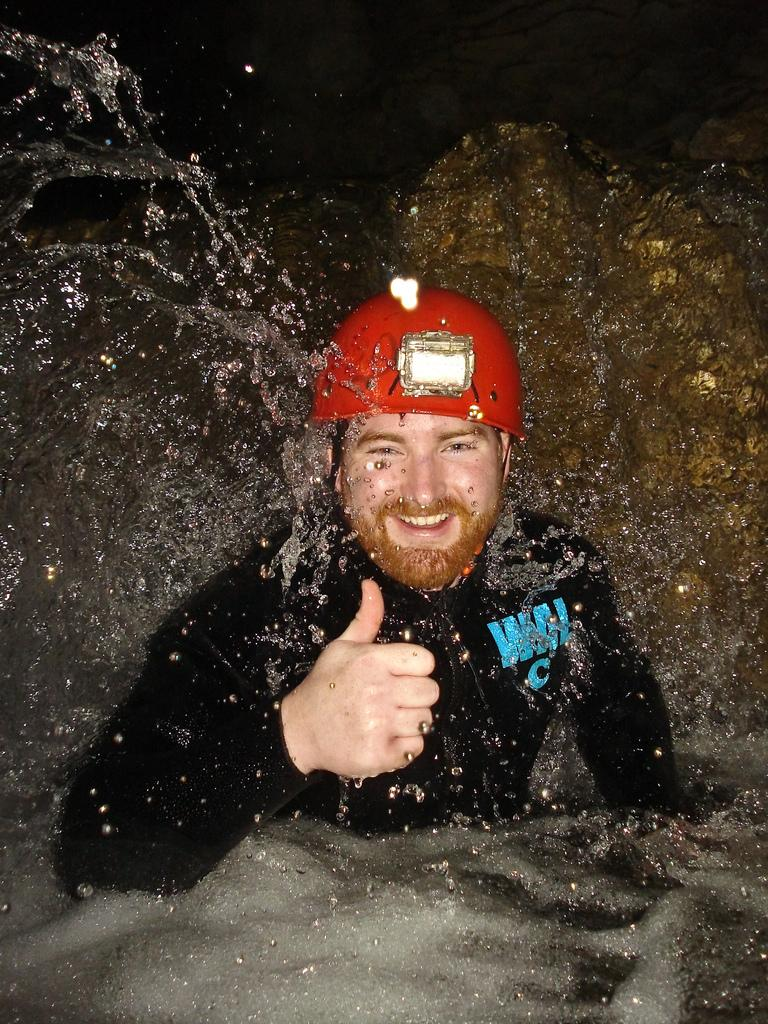What is the man in the image doing in the water? The man is in the water in the image. What is the man wearing on his body? The man is wearing a black dress. What type of headgear is the man wearing? The man is wearing a red helmet. What gesture is the man making with his hand? The man is showing his thumb. What is the shape of the heart floating in the water next to the man? There is no heart present in the image; it only features a man in the water wearing a black dress and red helmet, showing his thumb. 